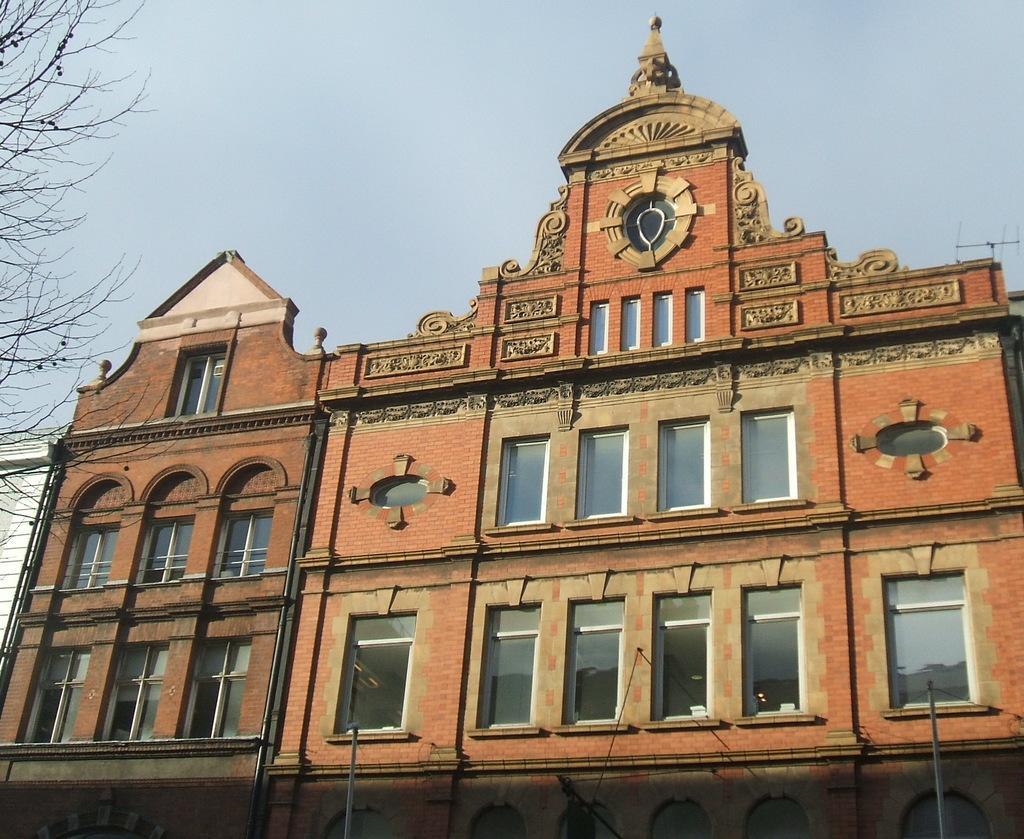In one or two sentences, can you explain what this image depicts? This picture is clicked outside. In the center there is a building and we can see the windows of the building and we can see the poles. In the background there is a sky. On the left corner we can see the tree. 